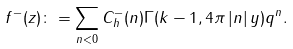<formula> <loc_0><loc_0><loc_500><loc_500>f ^ { - } ( z ) \colon = \sum _ { n < 0 } C _ { h } ^ { - } ( n ) \Gamma ( k - 1 , 4 \pi \left | n \right | y ) q ^ { n } .</formula> 